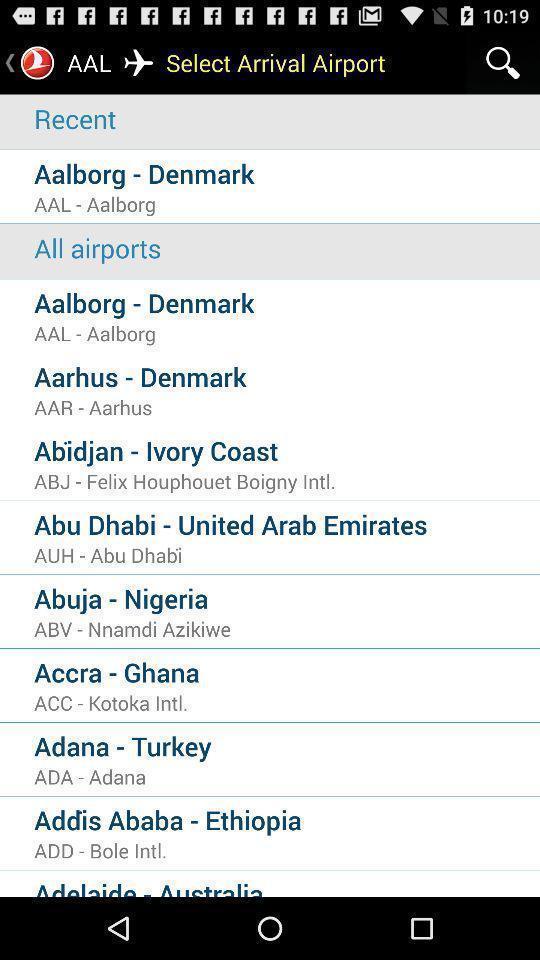Describe this image in words. Page showing search bar to find arrival airport. 